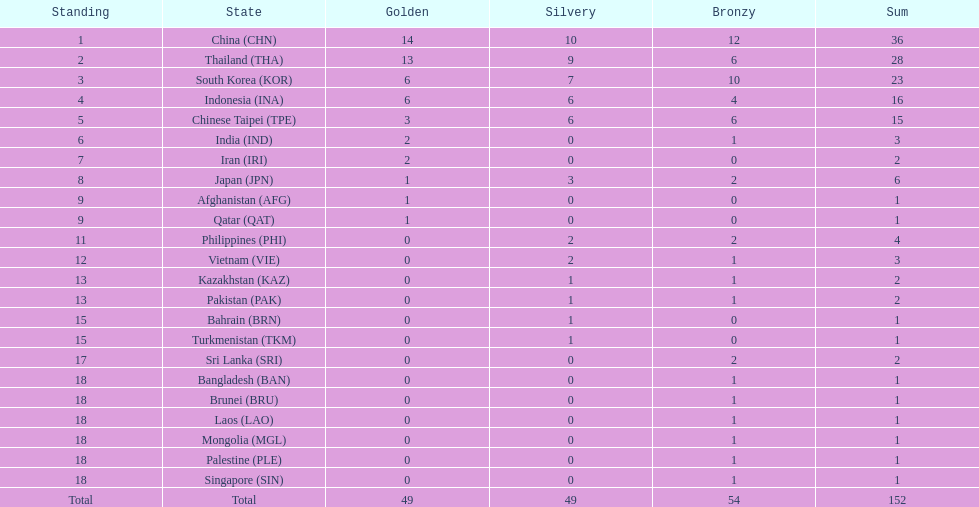Which countries won the same number of gold medals as japan? Afghanistan (AFG), Qatar (QAT). 